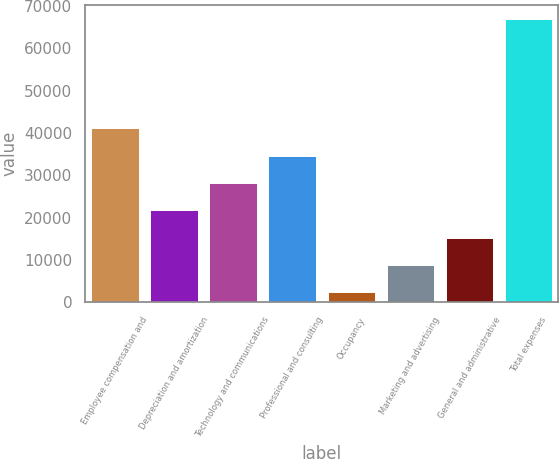Convert chart to OTSL. <chart><loc_0><loc_0><loc_500><loc_500><bar_chart><fcel>Employee compensation and<fcel>Depreciation and amortization<fcel>Technology and communications<fcel>Professional and consulting<fcel>Occupancy<fcel>Marketing and advertising<fcel>General and administrative<fcel>Total expenses<nl><fcel>41145.4<fcel>21755.2<fcel>28218.6<fcel>34682<fcel>2365<fcel>8828.4<fcel>15291.8<fcel>66999<nl></chart> 